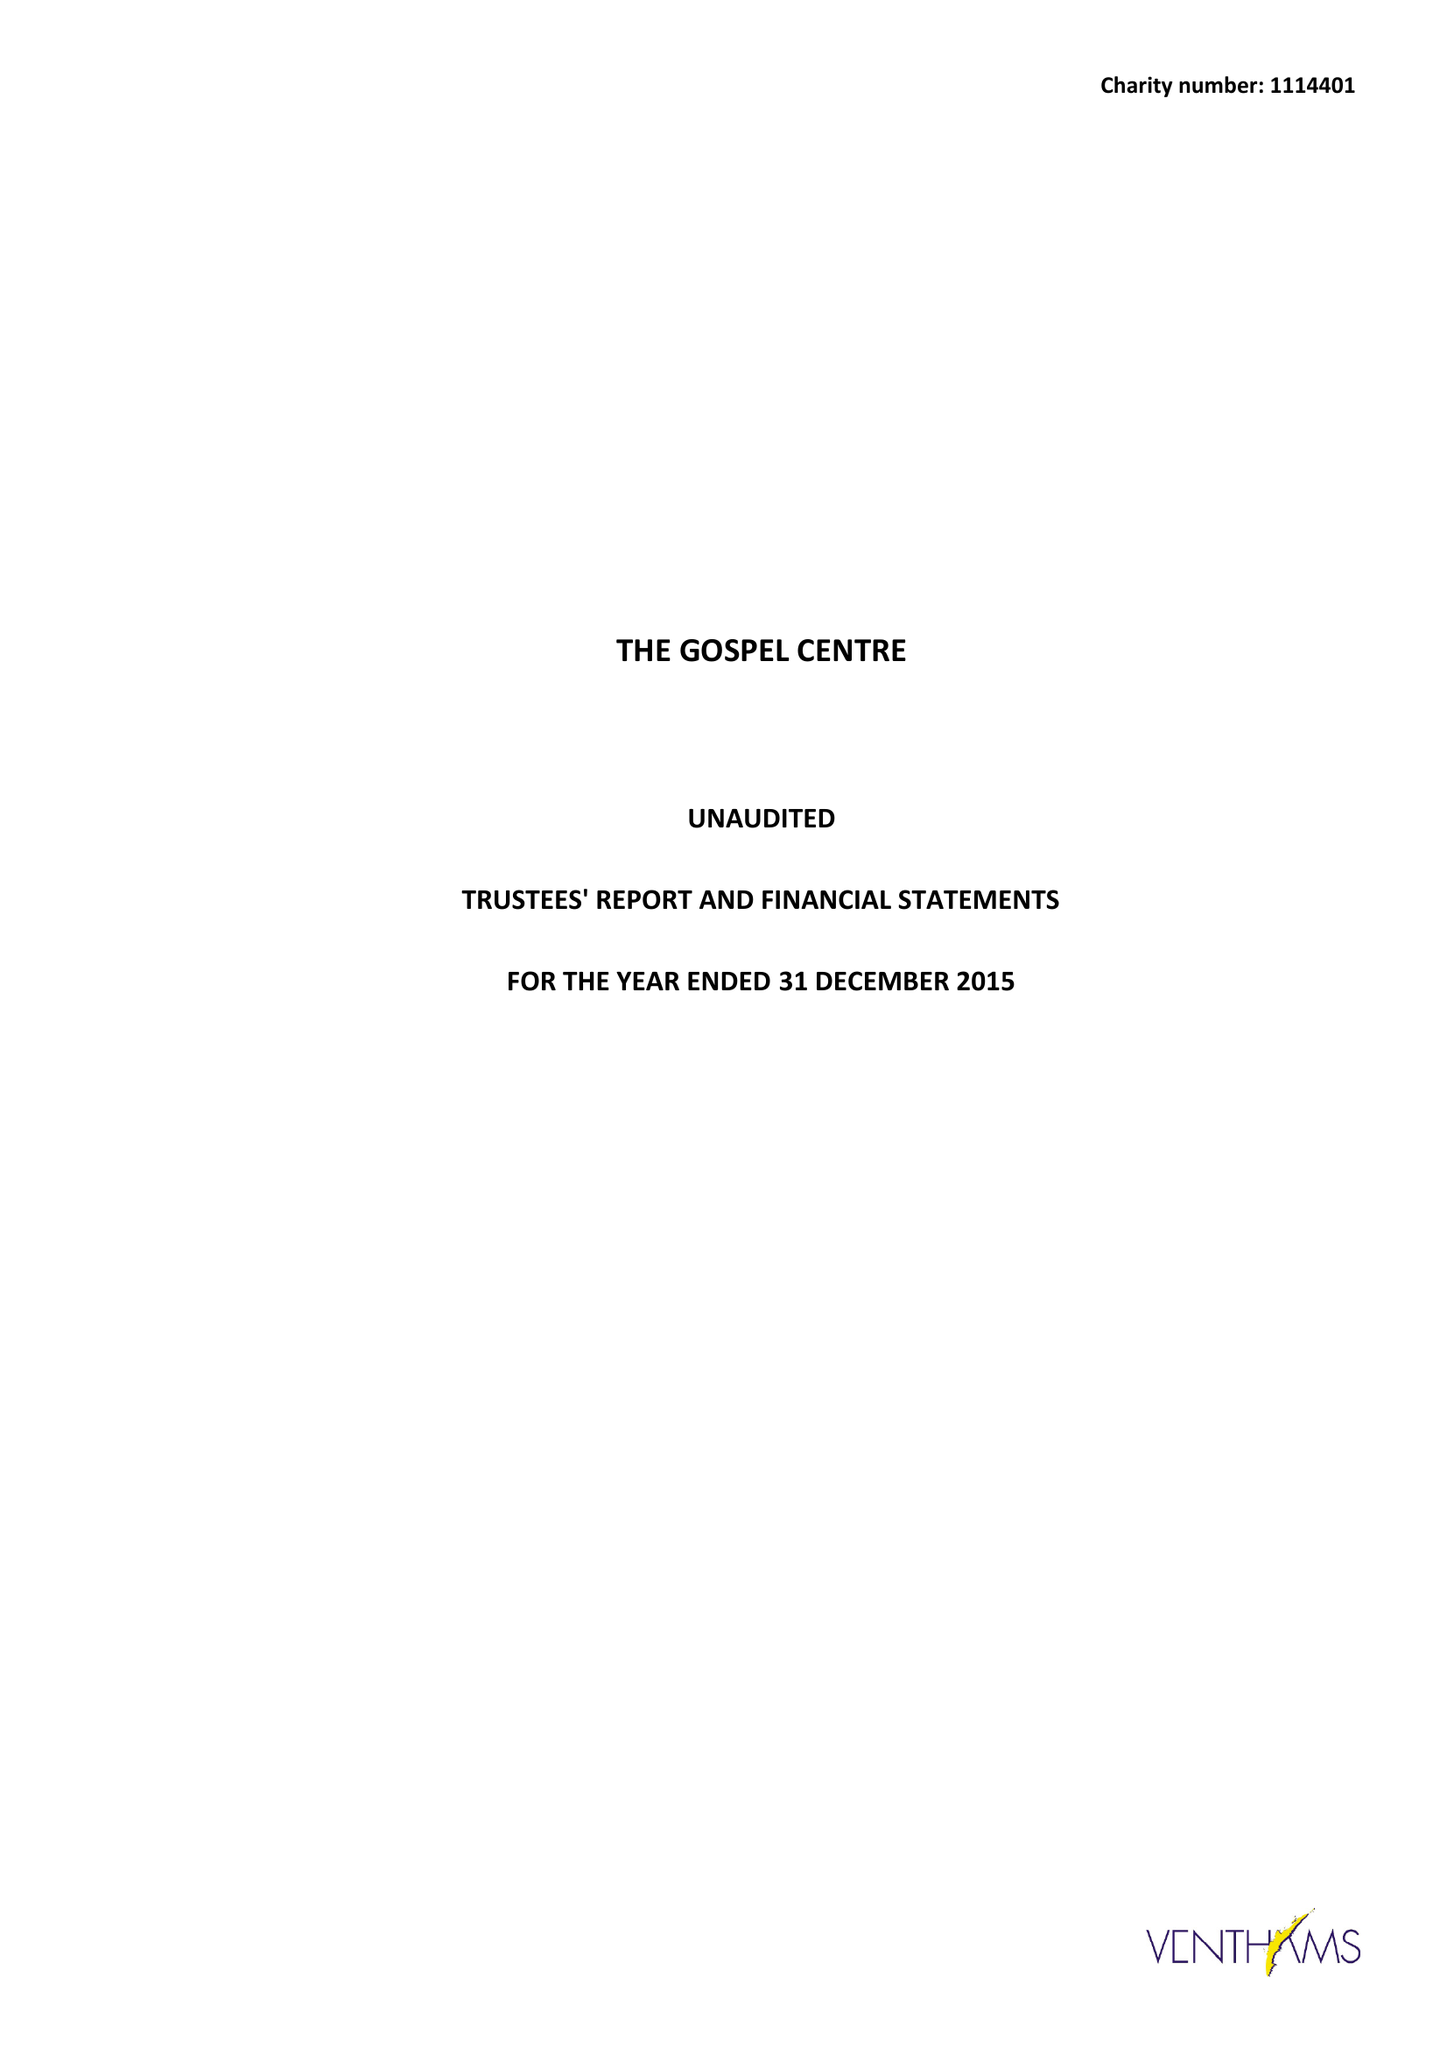What is the value for the address__street_line?
Answer the question using a single word or phrase. WIGHTMAN ROAD 